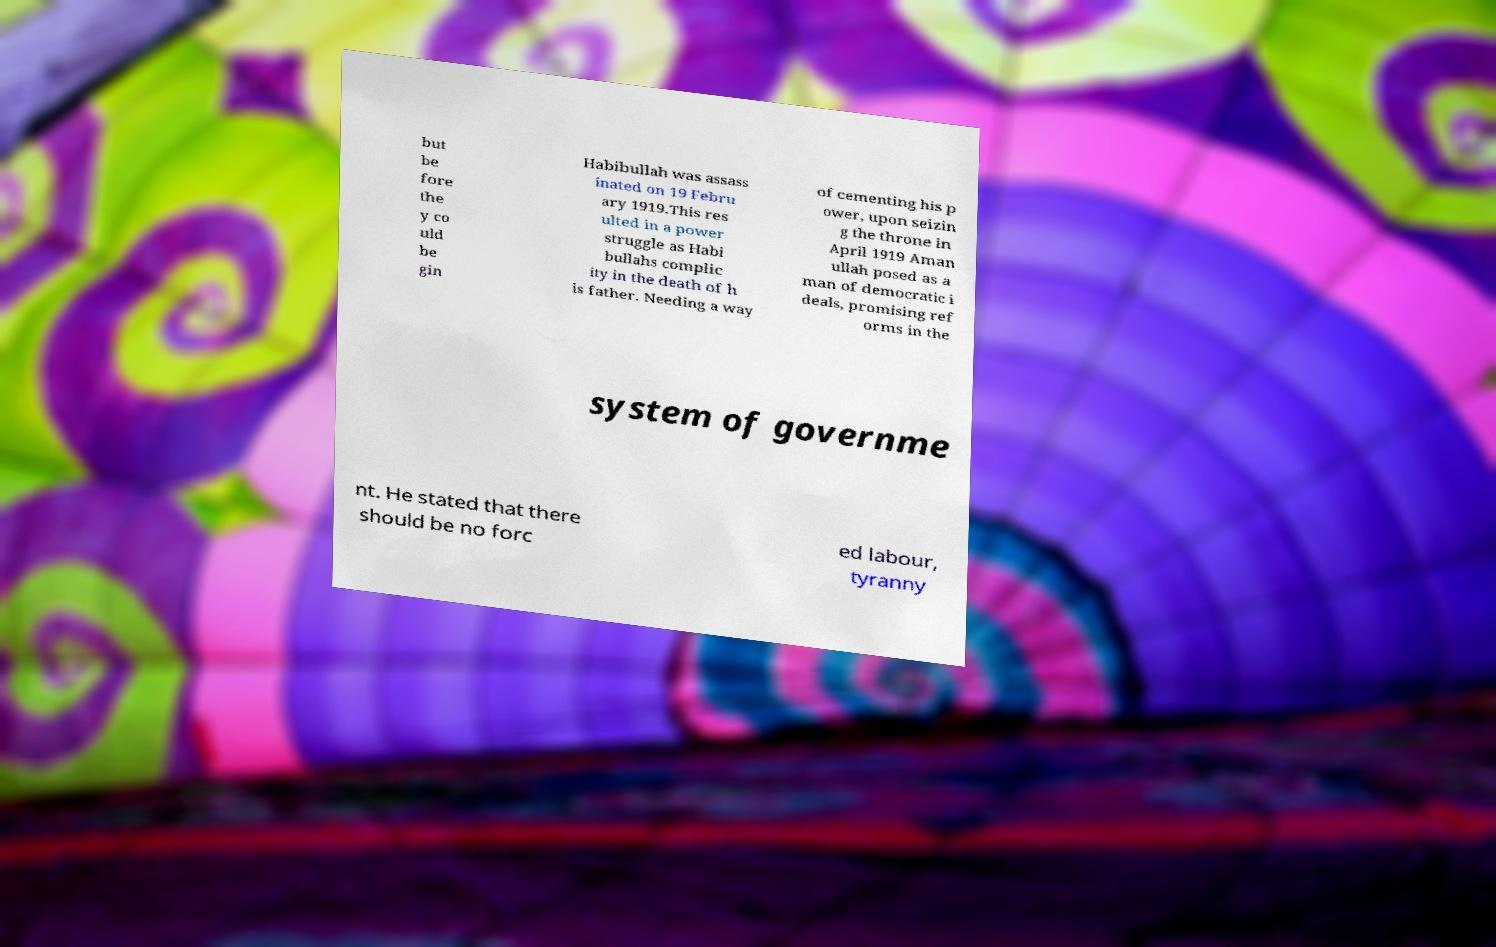There's text embedded in this image that I need extracted. Can you transcribe it verbatim? but be fore the y co uld be gin Habibullah was assass inated on 19 Febru ary 1919.This res ulted in a power struggle as Habi bullahs complic ity in the death of h is father. Needing a way of cementing his p ower, upon seizin g the throne in April 1919 Aman ullah posed as a man of democratic i deals, promising ref orms in the system of governme nt. He stated that there should be no forc ed labour, tyranny 